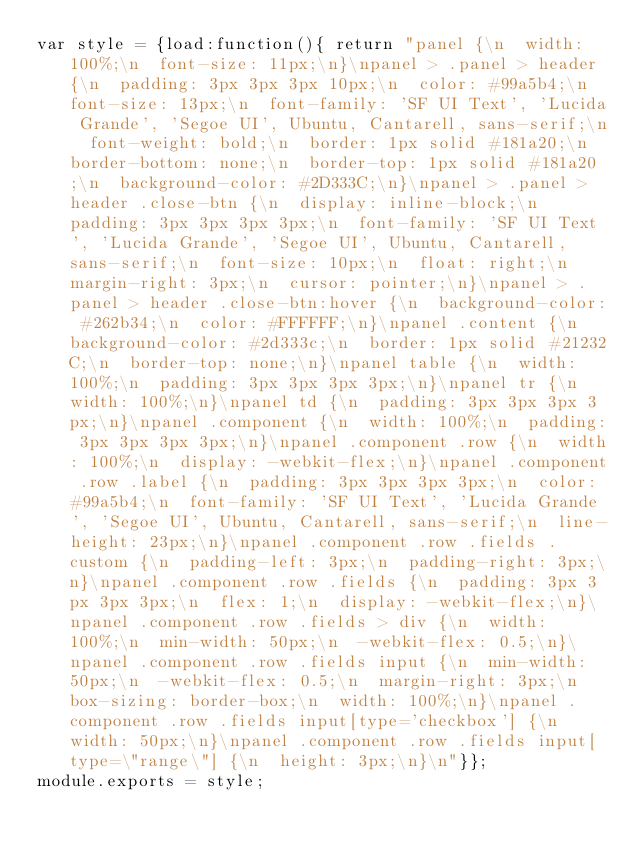Convert code to text. <code><loc_0><loc_0><loc_500><loc_500><_CSS_>var style = {load:function(){ return "panel {\n  width: 100%;\n  font-size: 11px;\n}\npanel > .panel > header {\n  padding: 3px 3px 3px 10px;\n  color: #99a5b4;\n  font-size: 13px;\n  font-family: 'SF UI Text', 'Lucida Grande', 'Segoe UI', Ubuntu, Cantarell, sans-serif;\n  font-weight: bold;\n  border: 1px solid #181a20;\n  border-bottom: none;\n  border-top: 1px solid #181a20;\n  background-color: #2D333C;\n}\npanel > .panel > header .close-btn {\n  display: inline-block;\n  padding: 3px 3px 3px 3px;\n  font-family: 'SF UI Text', 'Lucida Grande', 'Segoe UI', Ubuntu, Cantarell, sans-serif;\n  font-size: 10px;\n  float: right;\n  margin-right: 3px;\n  cursor: pointer;\n}\npanel > .panel > header .close-btn:hover {\n  background-color: #262b34;\n  color: #FFFFFF;\n}\npanel .content {\n  background-color: #2d333c;\n  border: 1px solid #21232C;\n  border-top: none;\n}\npanel table {\n  width: 100%;\n  padding: 3px 3px 3px 3px;\n}\npanel tr {\n  width: 100%;\n}\npanel td {\n  padding: 3px 3px 3px 3px;\n}\npanel .component {\n  width: 100%;\n  padding: 3px 3px 3px 3px;\n}\npanel .component .row {\n  width: 100%;\n  display: -webkit-flex;\n}\npanel .component .row .label {\n  padding: 3px 3px 3px 3px;\n  color: #99a5b4;\n  font-family: 'SF UI Text', 'Lucida Grande', 'Segoe UI', Ubuntu, Cantarell, sans-serif;\n  line-height: 23px;\n}\npanel .component .row .fields .custom {\n  padding-left: 3px;\n  padding-right: 3px;\n}\npanel .component .row .fields {\n  padding: 3px 3px 3px 3px;\n  flex: 1;\n  display: -webkit-flex;\n}\npanel .component .row .fields > div {\n  width: 100%;\n  min-width: 50px;\n  -webkit-flex: 0.5;\n}\npanel .component .row .fields input {\n  min-width: 50px;\n  -webkit-flex: 0.5;\n  margin-right: 3px;\n  box-sizing: border-box;\n  width: 100%;\n}\npanel .component .row .fields input[type='checkbox'] {\n  width: 50px;\n}\npanel .component .row .fields input[type=\"range\"] {\n  height: 3px;\n}\n"}};
module.exports = style;
</code> 